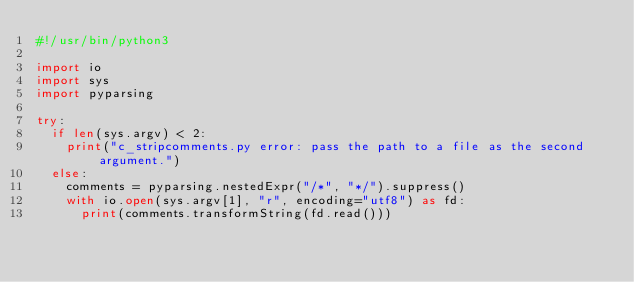<code> <loc_0><loc_0><loc_500><loc_500><_Python_>#!/usr/bin/python3

import io
import sys
import pyparsing

try:
  if len(sys.argv) < 2:
    print("c_stripcomments.py error: pass the path to a file as the second argument.")
  else:
    comments = pyparsing.nestedExpr("/*", "*/").suppress()
    with io.open(sys.argv[1], "r", encoding="utf8") as fd:
      print(comments.transformString(fd.read()))</code> 